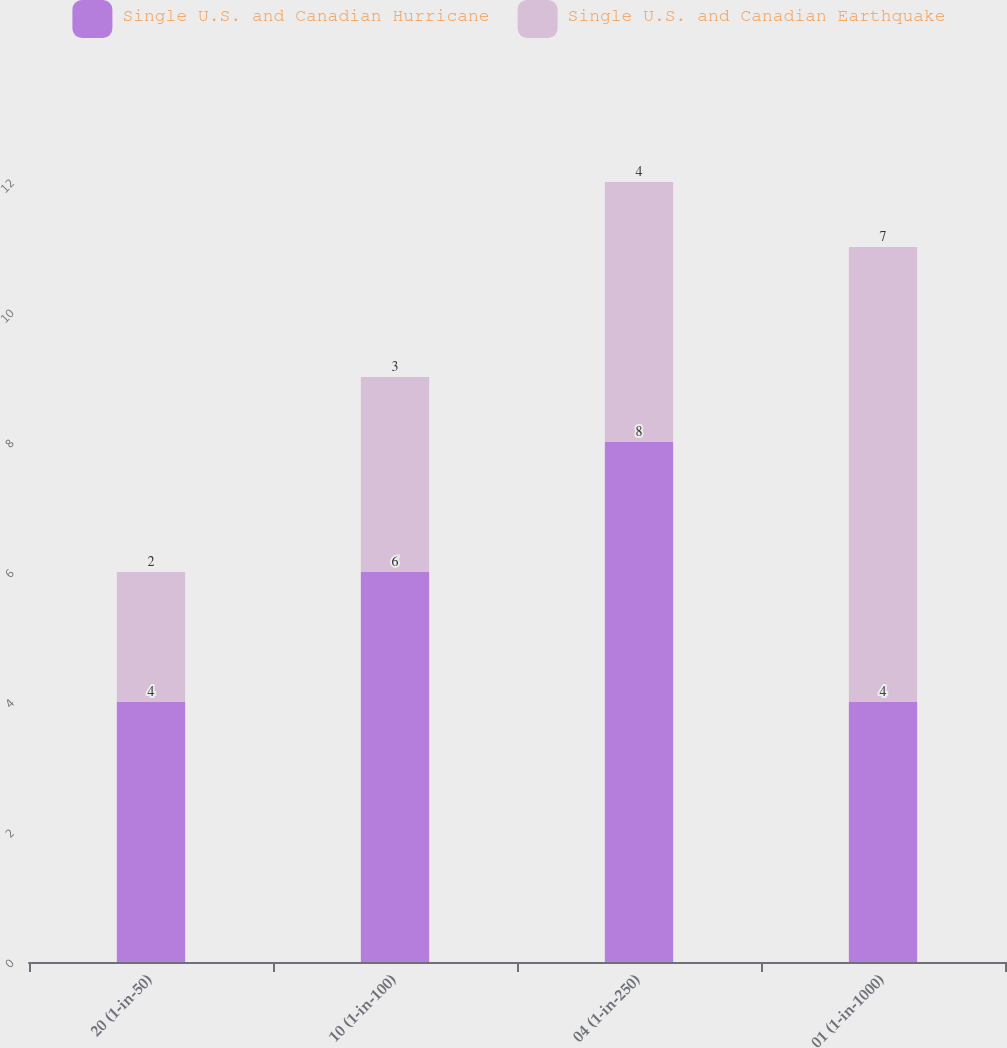<chart> <loc_0><loc_0><loc_500><loc_500><stacked_bar_chart><ecel><fcel>20 (1-in-50)<fcel>10 (1-in-100)<fcel>04 (1-in-250)<fcel>01 (1-in-1000)<nl><fcel>Single U.S. and Canadian Hurricane<fcel>4<fcel>6<fcel>8<fcel>4<nl><fcel>Single U.S. and Canadian Earthquake<fcel>2<fcel>3<fcel>4<fcel>7<nl></chart> 